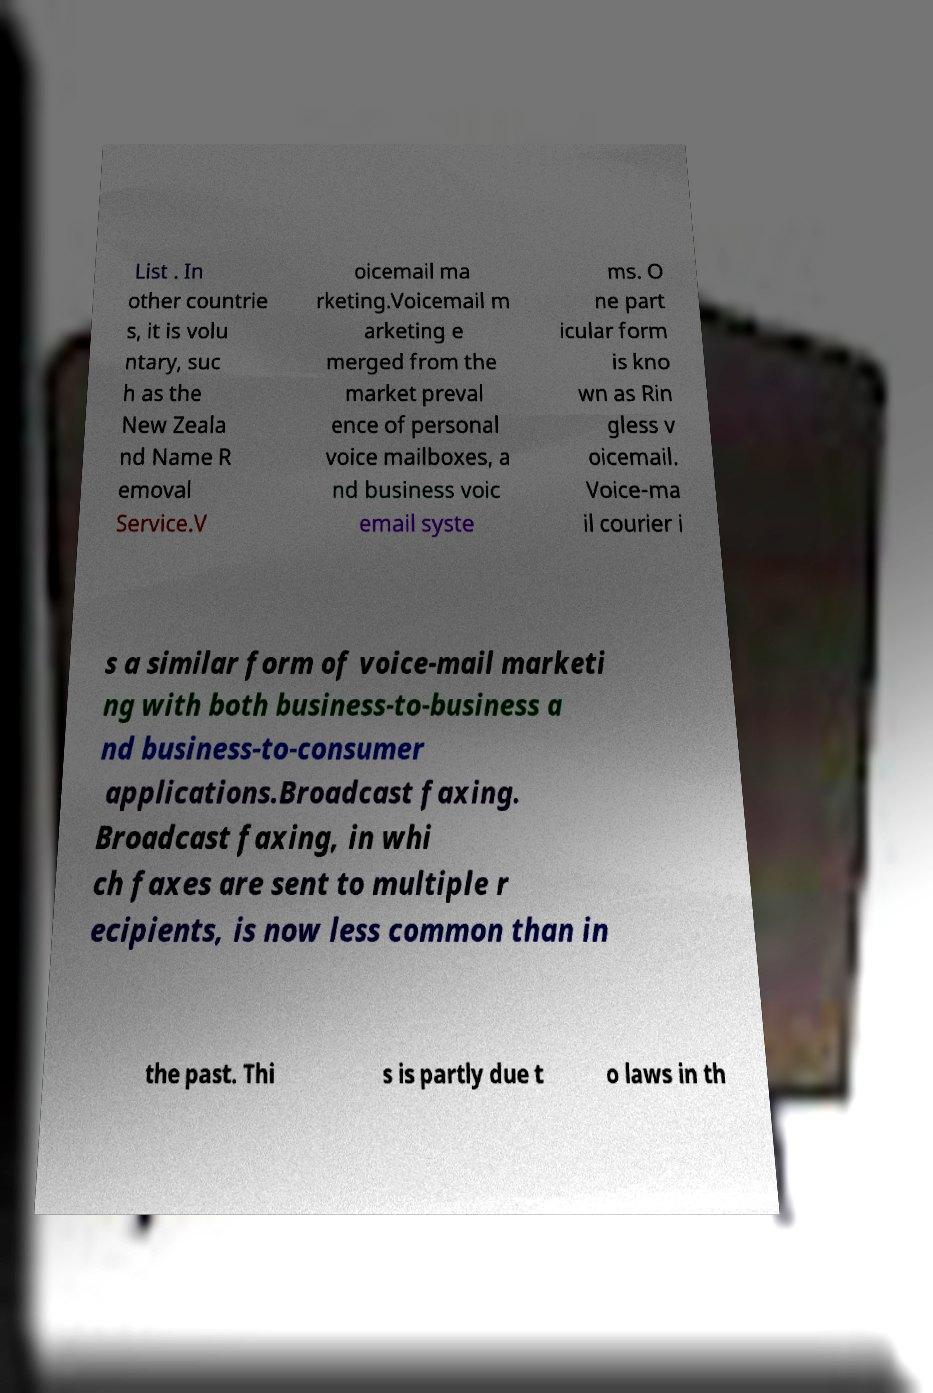I need the written content from this picture converted into text. Can you do that? List . In other countrie s, it is volu ntary, suc h as the New Zeala nd Name R emoval Service.V oicemail ma rketing.Voicemail m arketing e merged from the market preval ence of personal voice mailboxes, a nd business voic email syste ms. O ne part icular form is kno wn as Rin gless v oicemail. Voice-ma il courier i s a similar form of voice-mail marketi ng with both business-to-business a nd business-to-consumer applications.Broadcast faxing. Broadcast faxing, in whi ch faxes are sent to multiple r ecipients, is now less common than in the past. Thi s is partly due t o laws in th 